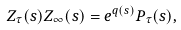Convert formula to latex. <formula><loc_0><loc_0><loc_500><loc_500>Z _ { \tau } ( s ) Z _ { \infty } ( s ) = e ^ { q ( s ) } P _ { \tau } ( s ) ,</formula> 